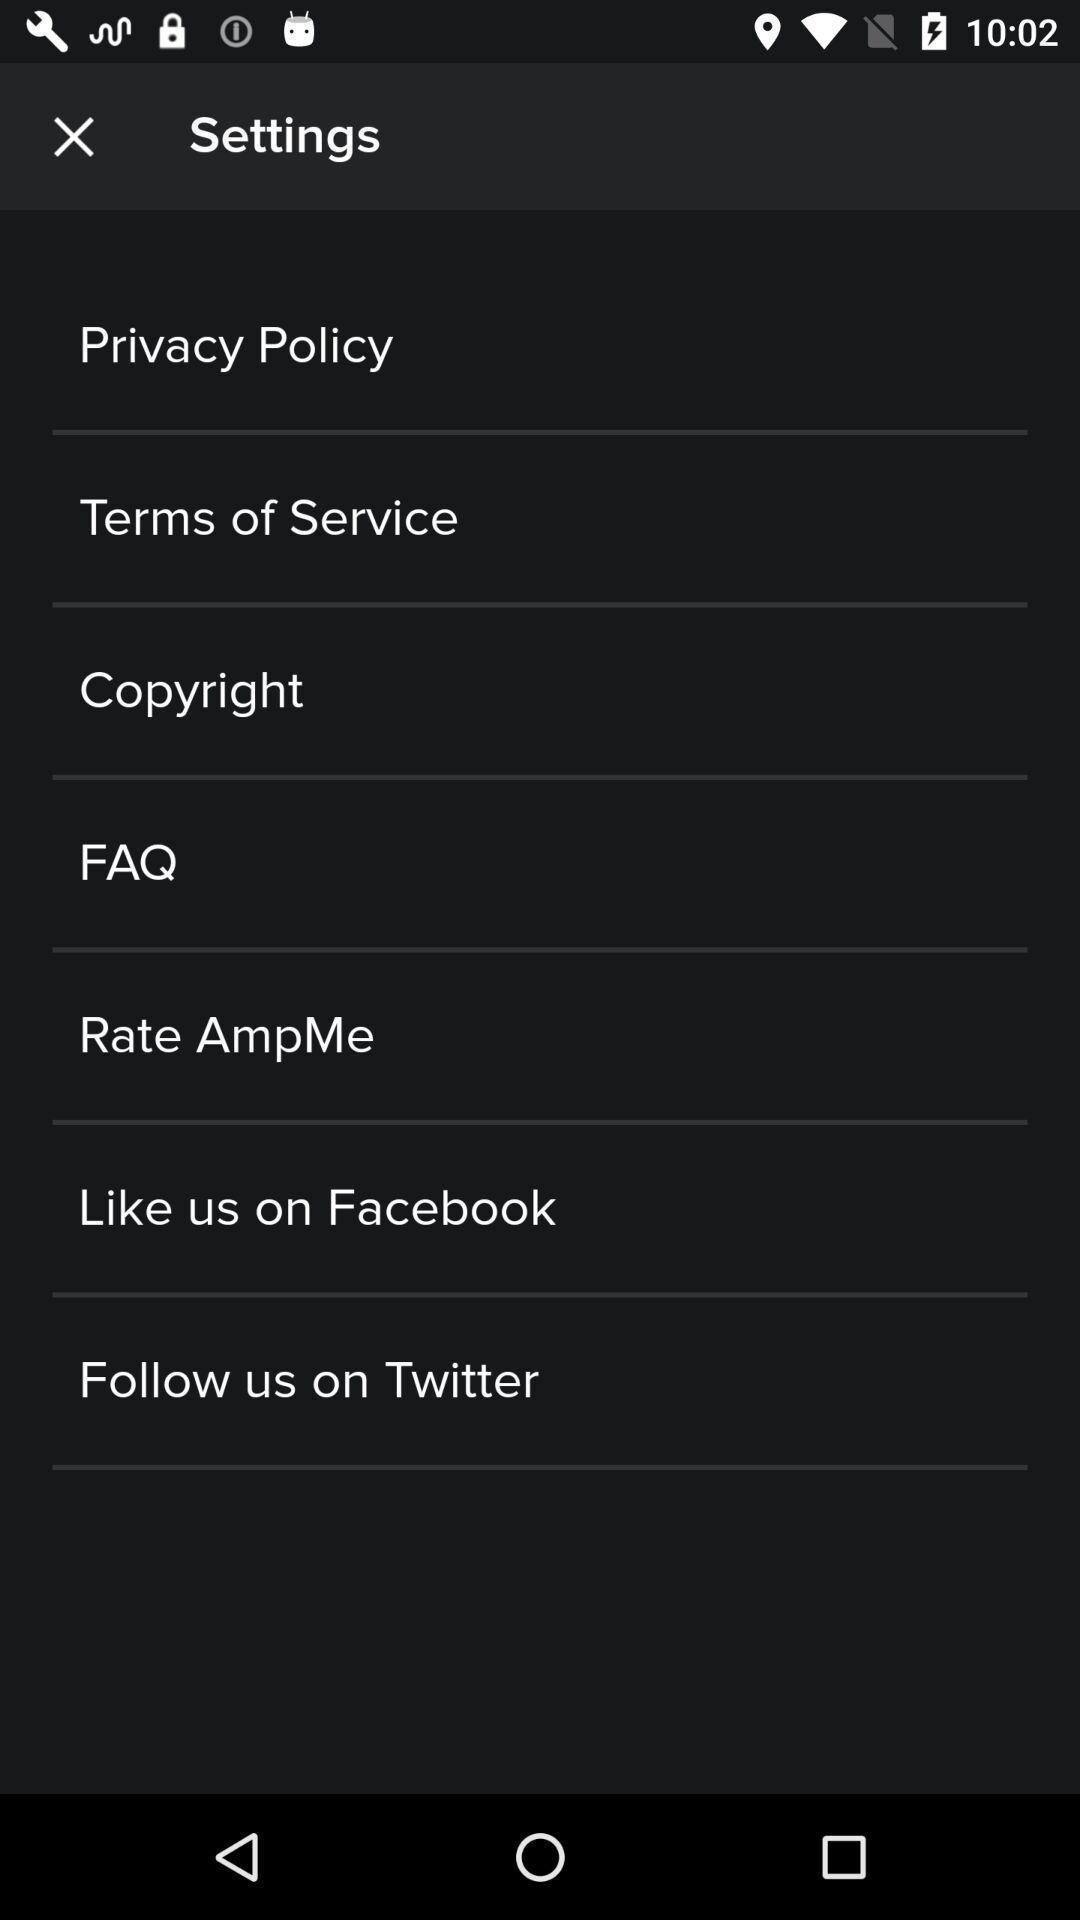Please provide a description for this image. Settings page. 